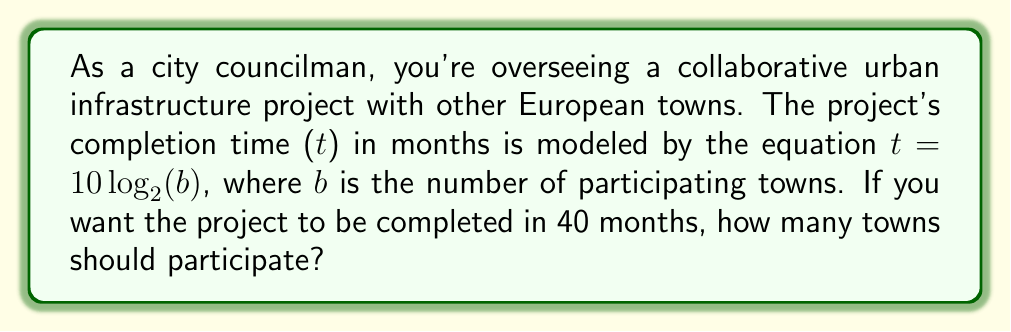Can you answer this question? Let's approach this step-by-step:

1) We're given the equation: $t = 10 \log_2(b)$
   Where t is time in months and b is the number of towns.

2) We want t to be 40 months, so let's substitute this:
   $40 = 10 \log_2(b)$

3) Divide both sides by 10:
   $4 = \log_2(b)$

4) To solve for b, we need to apply the inverse function (exponential) to both sides:
   $2^4 = 2^{\log_2(b)}$

5) The left side simplifies to:
   $16 = 2^{\log_2(b)}$

6) A property of logarithms states that $2^{\log_2(b)} = b$, so:
   $16 = b$

Therefore, 16 towns should participate to complete the project in 40 months.
Answer: 16 towns 